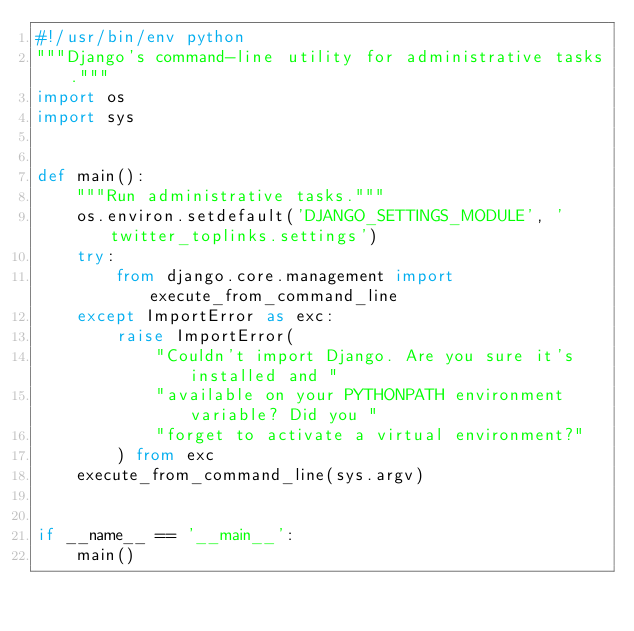Convert code to text. <code><loc_0><loc_0><loc_500><loc_500><_Python_>#!/usr/bin/env python
"""Django's command-line utility for administrative tasks."""
import os
import sys


def main():
    """Run administrative tasks."""
    os.environ.setdefault('DJANGO_SETTINGS_MODULE', 'twitter_toplinks.settings')
    try:
        from django.core.management import execute_from_command_line
    except ImportError as exc:
        raise ImportError(
            "Couldn't import Django. Are you sure it's installed and "
            "available on your PYTHONPATH environment variable? Did you "
            "forget to activate a virtual environment?"
        ) from exc
    execute_from_command_line(sys.argv)


if __name__ == '__main__':
    main()
</code> 